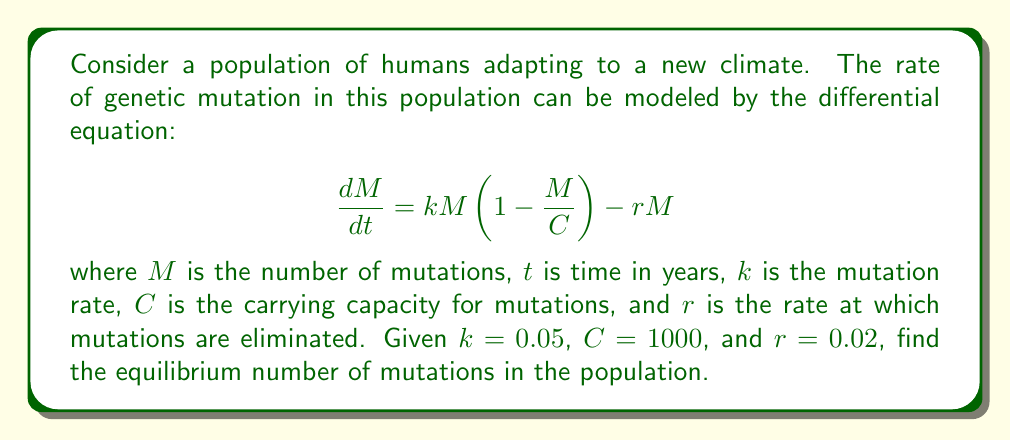Solve this math problem. To find the equilibrium number of mutations, we need to set the rate of change of mutations to zero:

1) Set $\frac{dM}{dt} = 0$:

   $$0 = kM(1 - \frac{M}{C}) - rM$$

2) Substitute the given values:

   $$0 = 0.05M(1 - \frac{M}{1000}) - 0.02M$$

3) Expand the equation:

   $$0 = 0.05M - \frac{0.05M^2}{1000} - 0.02M$$

4) Simplify:

   $$0 = 0.03M - \frac{0.05M^2}{1000}$$

5) Multiply both sides by 1000:

   $$0 = 30M - 0.05M^2$$

6) Rearrange to standard quadratic form:

   $$0.05M^2 - 30M = 0$$

7) Factor out M:

   $$M(0.05M - 30) = 0$$

8) Solve for M:
   
   $M = 0$ or $0.05M - 30 = 0$
   
   For the non-zero solution: $M = \frac{30}{0.05} = 600$

The biologically relevant solution is 600, as 0 mutations would not represent an adapting population.
Answer: 600 mutations 